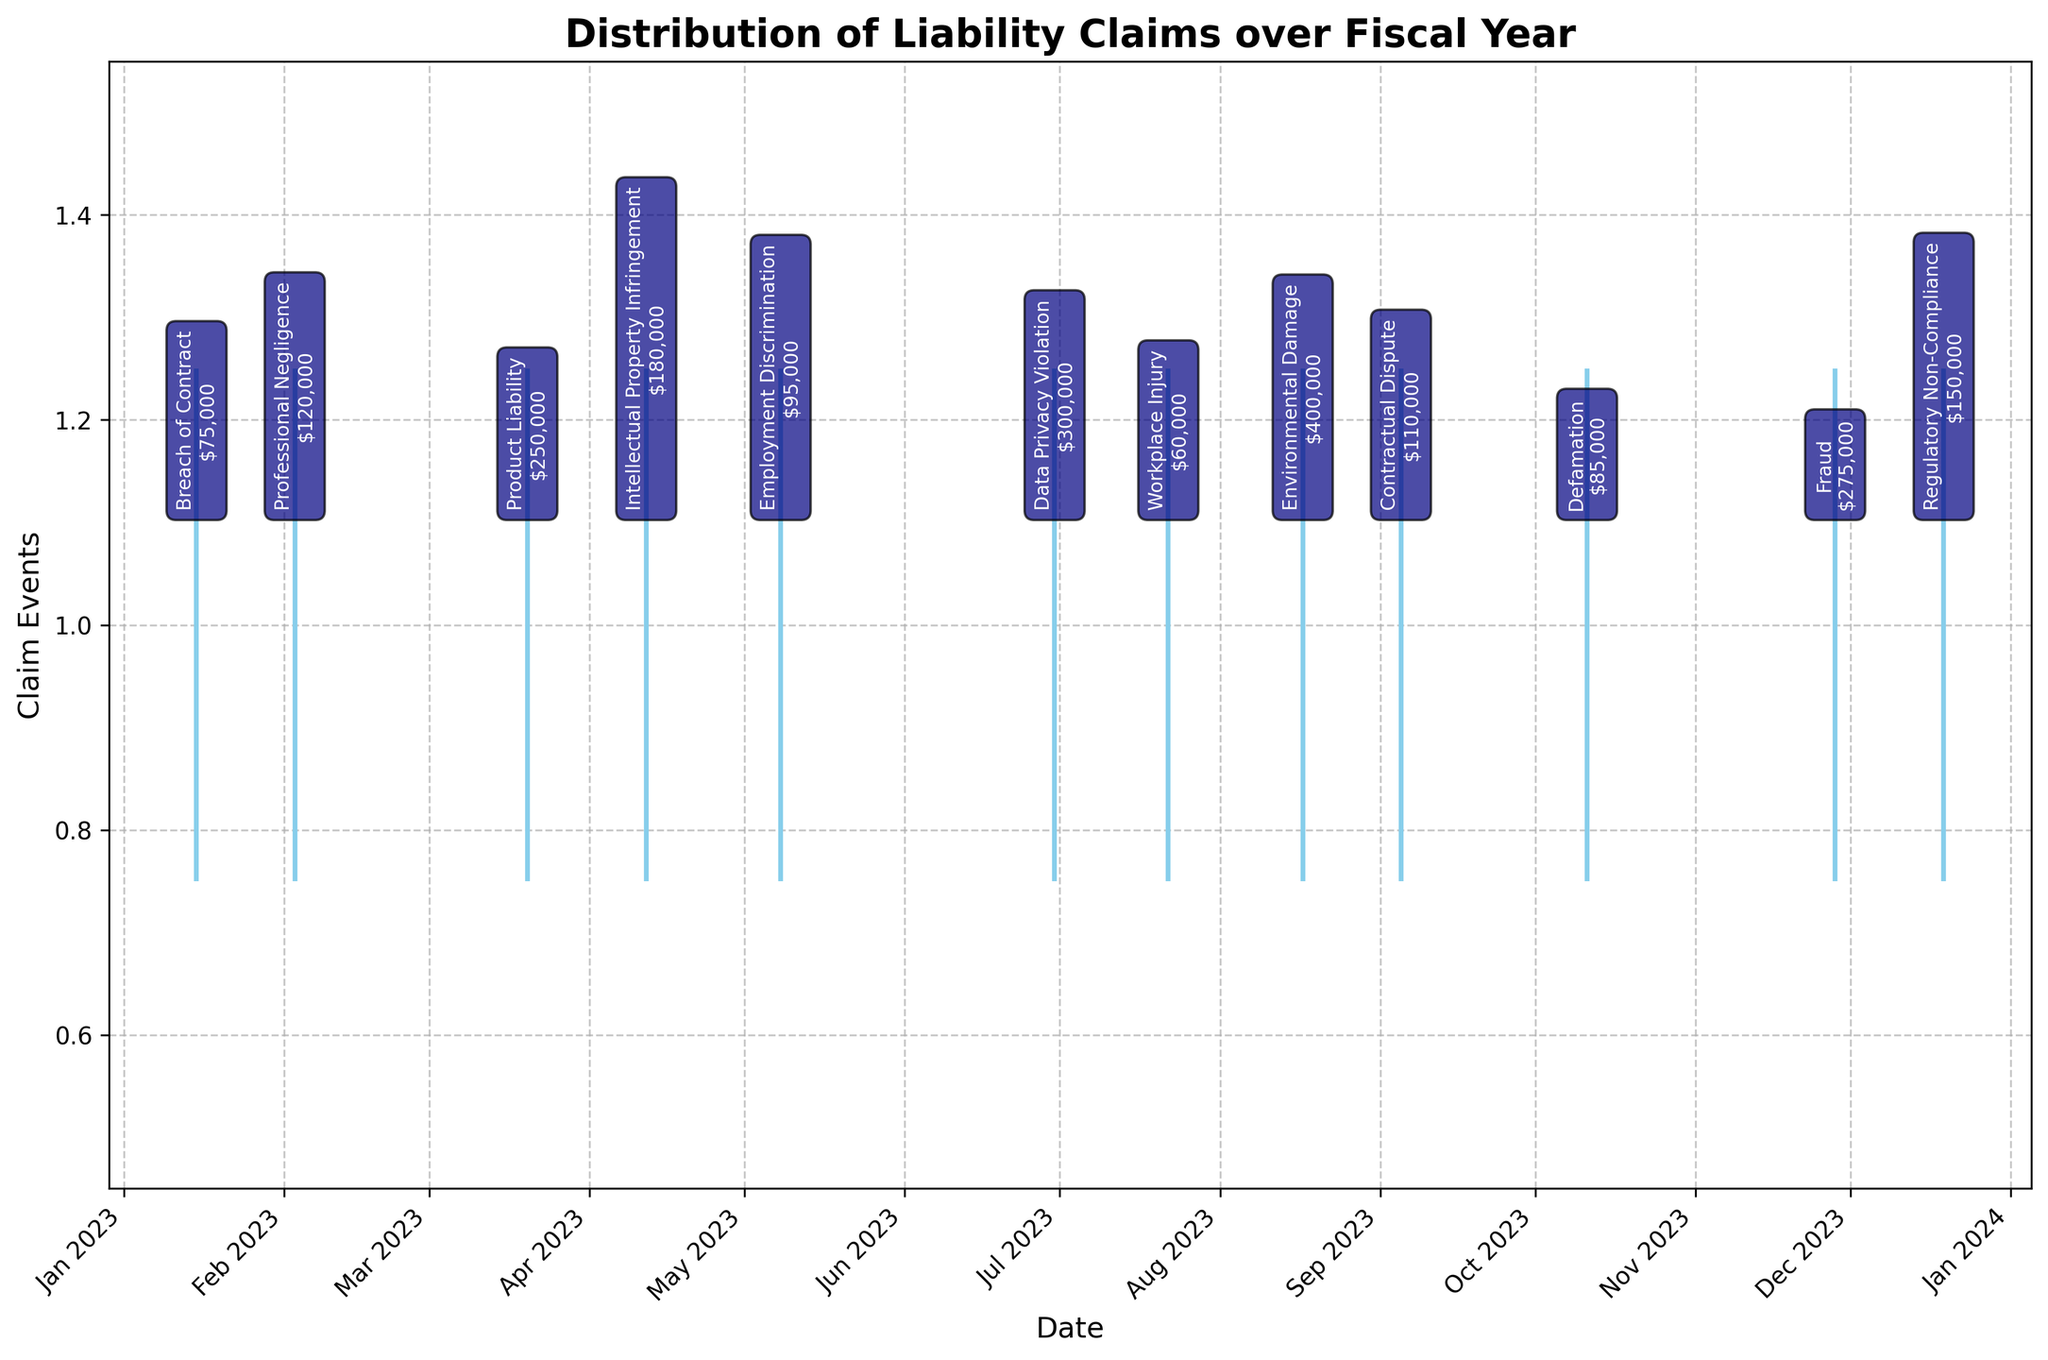What's the title of the plot? The title is displayed at the top of the plot and reads "Distribution of Liability Claims over Fiscal Year".
Answer: Distribution of Liability Claims over Fiscal Year How many claim events are depicted over the fiscal year? Each horizontal line represents a claim event, and counting them reveals there are 12 claim events.
Answer: 12 Which month had the highest total claim amount, and what was the amount? By examining the claim annotations, August shows an Environmental Damage claim of $400,000, the highest amount in a single month.
Answer: August, $400,000 What types of claims were made in January and April? January shows "Breach of Contract" and April shows "Intellectual Property Infringement" based on the annotations.
Answer: Breach of Contract in January, Intellectual Property Infringement in April What is the average claim amount over the fiscal year? Adding all the claim amounts ($75,000 + $120,000 + $250,000 + $180,000 + $95,000 + $300,000 + $60,000 + $400,000 + $110,000 + $85,000 + $275,000 + $150,000) and dividing by the 12 claims gives the average: $2,100,000 / 12 = $175,000
Answer: $175,000 Which month shows claims for both Workplace Injury and Contractual Dispute? By checking the months and annotations, July shows "Workplace Injury" and September shows "Contractual Dispute". No single month has both.
Answer: None Compare the claim amount for Professional Negligence and Fraud. Which one is higher? Based on the annotations, Professional Negligence is $120,000 and Fraud is $275,000. Fraud is higher.
Answer: Fraud How many claim types are depicted in total? Each unique claim type is counted: "Breach of Contract", "Professional Negligence", "Product Liability", "Intellectual Property Infringement", "Employment Discrimination", "Data Privacy Violation", "Workplace Injury", "Environmental Damage", "Contractual Dispute", "Defamation", "Fraud", "Regulatory Non-Compliance", totaling to 12 unique types.
Answer: 12 